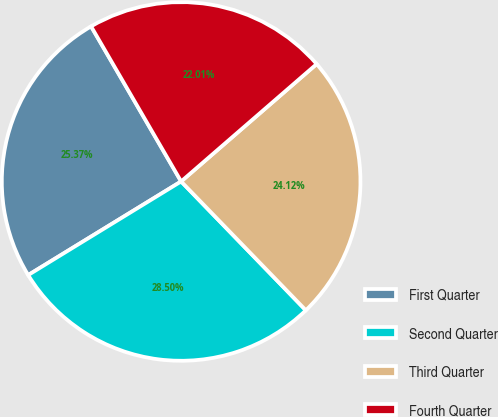<chart> <loc_0><loc_0><loc_500><loc_500><pie_chart><fcel>First Quarter<fcel>Second Quarter<fcel>Third Quarter<fcel>Fourth Quarter<nl><fcel>25.37%<fcel>28.5%<fcel>24.12%<fcel>22.01%<nl></chart> 